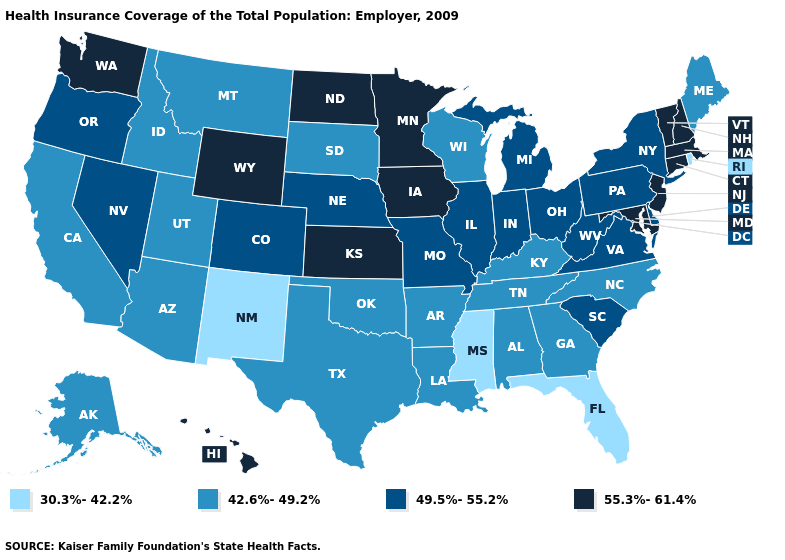What is the value of North Dakota?
Quick response, please. 55.3%-61.4%. Which states hav the highest value in the West?
Concise answer only. Hawaii, Washington, Wyoming. Name the states that have a value in the range 30.3%-42.2%?
Answer briefly. Florida, Mississippi, New Mexico, Rhode Island. Among the states that border Massachusetts , does New York have the highest value?
Give a very brief answer. No. Does the first symbol in the legend represent the smallest category?
Answer briefly. Yes. Name the states that have a value in the range 42.6%-49.2%?
Be succinct. Alabama, Alaska, Arizona, Arkansas, California, Georgia, Idaho, Kentucky, Louisiana, Maine, Montana, North Carolina, Oklahoma, South Dakota, Tennessee, Texas, Utah, Wisconsin. Which states have the lowest value in the West?
Give a very brief answer. New Mexico. What is the value of Alaska?
Concise answer only. 42.6%-49.2%. Which states have the highest value in the USA?
Be succinct. Connecticut, Hawaii, Iowa, Kansas, Maryland, Massachusetts, Minnesota, New Hampshire, New Jersey, North Dakota, Vermont, Washington, Wyoming. Name the states that have a value in the range 30.3%-42.2%?
Answer briefly. Florida, Mississippi, New Mexico, Rhode Island. What is the value of Missouri?
Concise answer only. 49.5%-55.2%. Which states hav the highest value in the MidWest?
Be succinct. Iowa, Kansas, Minnesota, North Dakota. Name the states that have a value in the range 42.6%-49.2%?
Write a very short answer. Alabama, Alaska, Arizona, Arkansas, California, Georgia, Idaho, Kentucky, Louisiana, Maine, Montana, North Carolina, Oklahoma, South Dakota, Tennessee, Texas, Utah, Wisconsin. What is the lowest value in the USA?
Write a very short answer. 30.3%-42.2%. What is the lowest value in states that border Oregon?
Concise answer only. 42.6%-49.2%. 